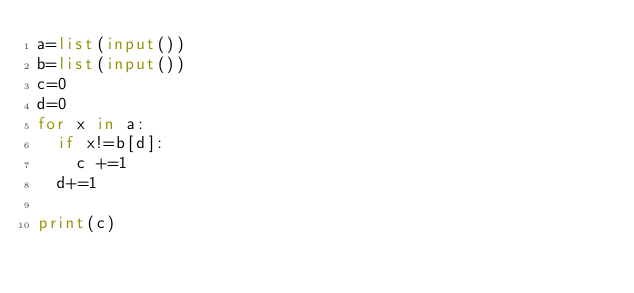Convert code to text. <code><loc_0><loc_0><loc_500><loc_500><_Python_>a=list(input())
b=list(input())
c=0
d=0
for x in a:
  if x!=b[d]:
    c +=1
  d+=1

print(c)</code> 